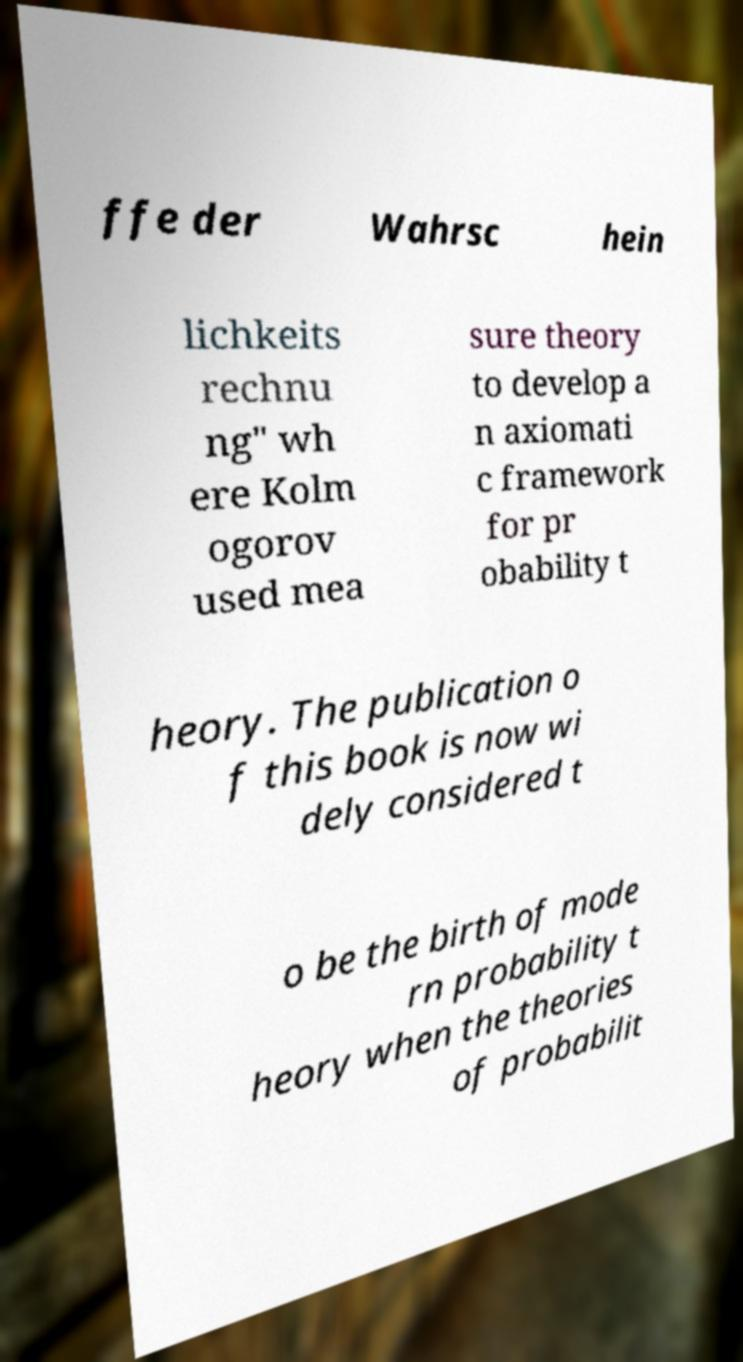I need the written content from this picture converted into text. Can you do that? ffe der Wahrsc hein lichkeits rechnu ng" wh ere Kolm ogorov used mea sure theory to develop a n axiomati c framework for pr obability t heory. The publication o f this book is now wi dely considered t o be the birth of mode rn probability t heory when the theories of probabilit 